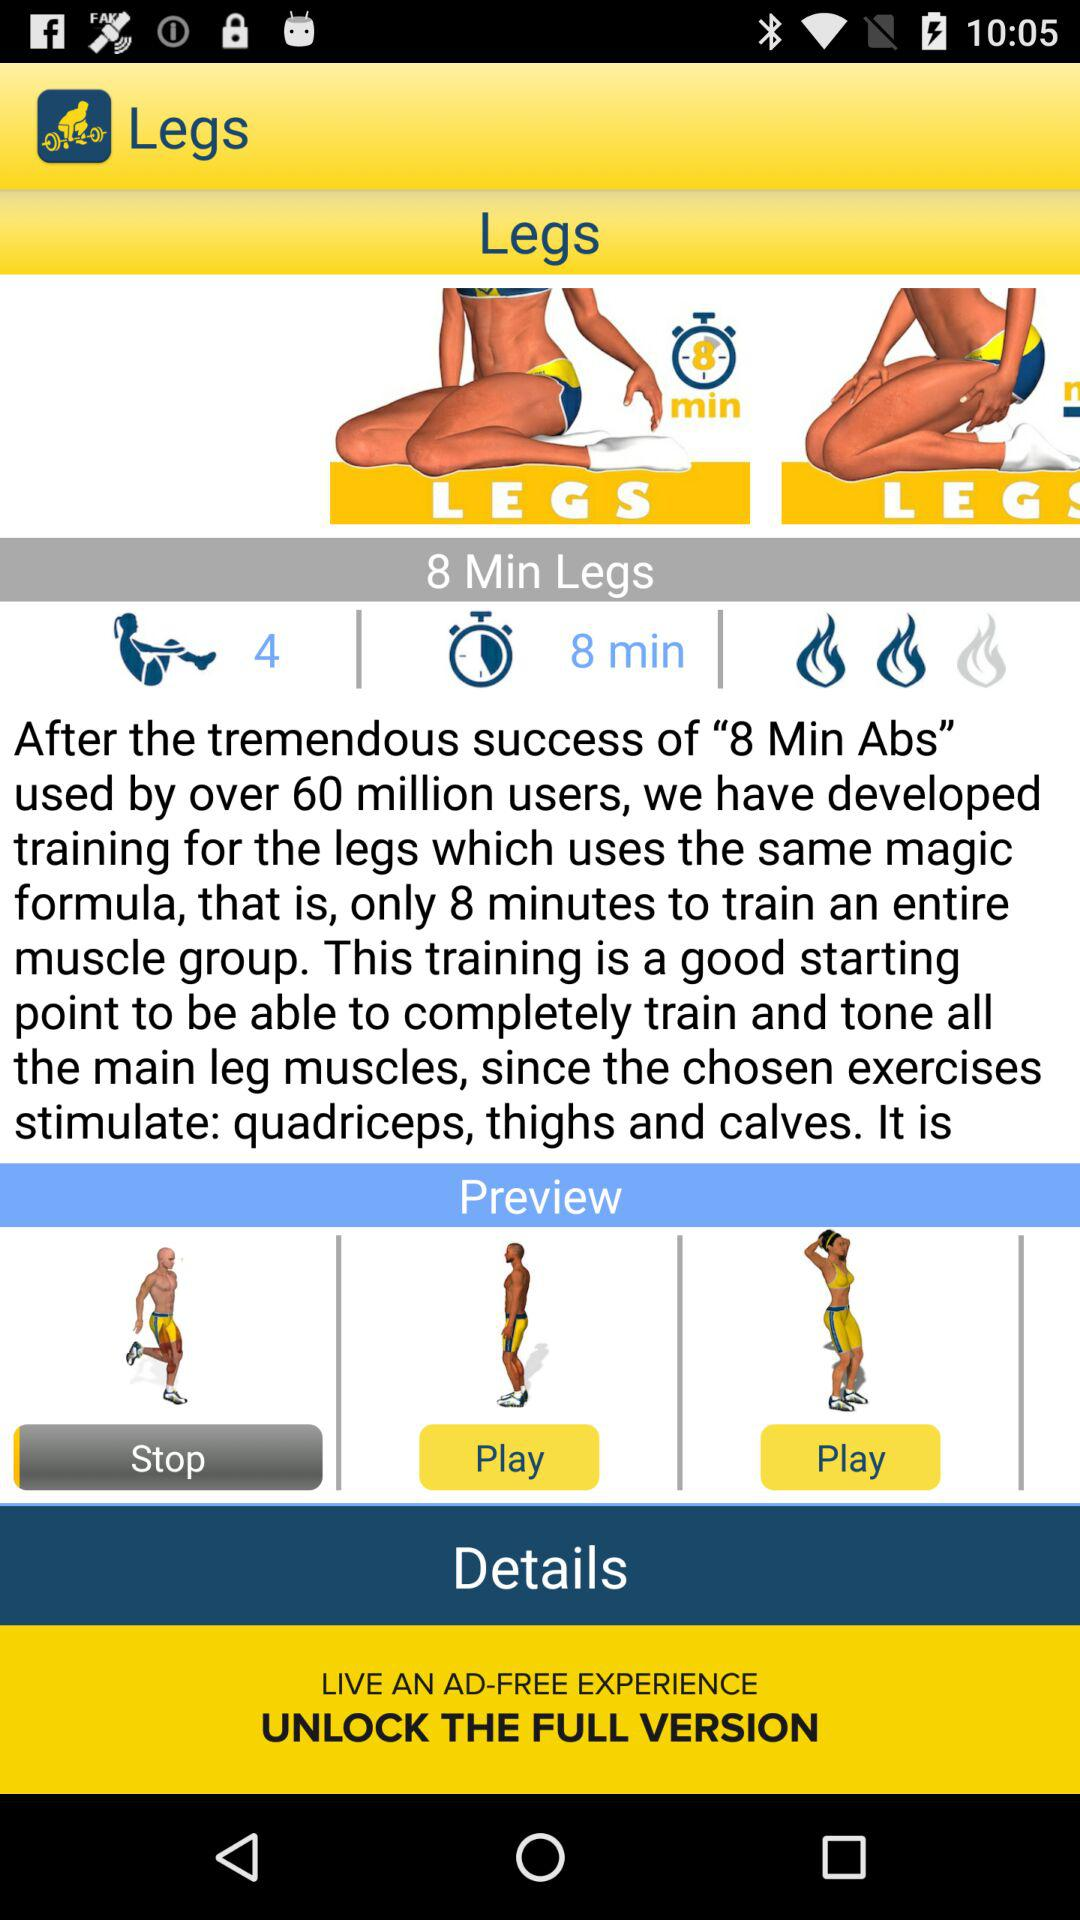What is the application name? The application name is "Legs Workout and Exercises". 